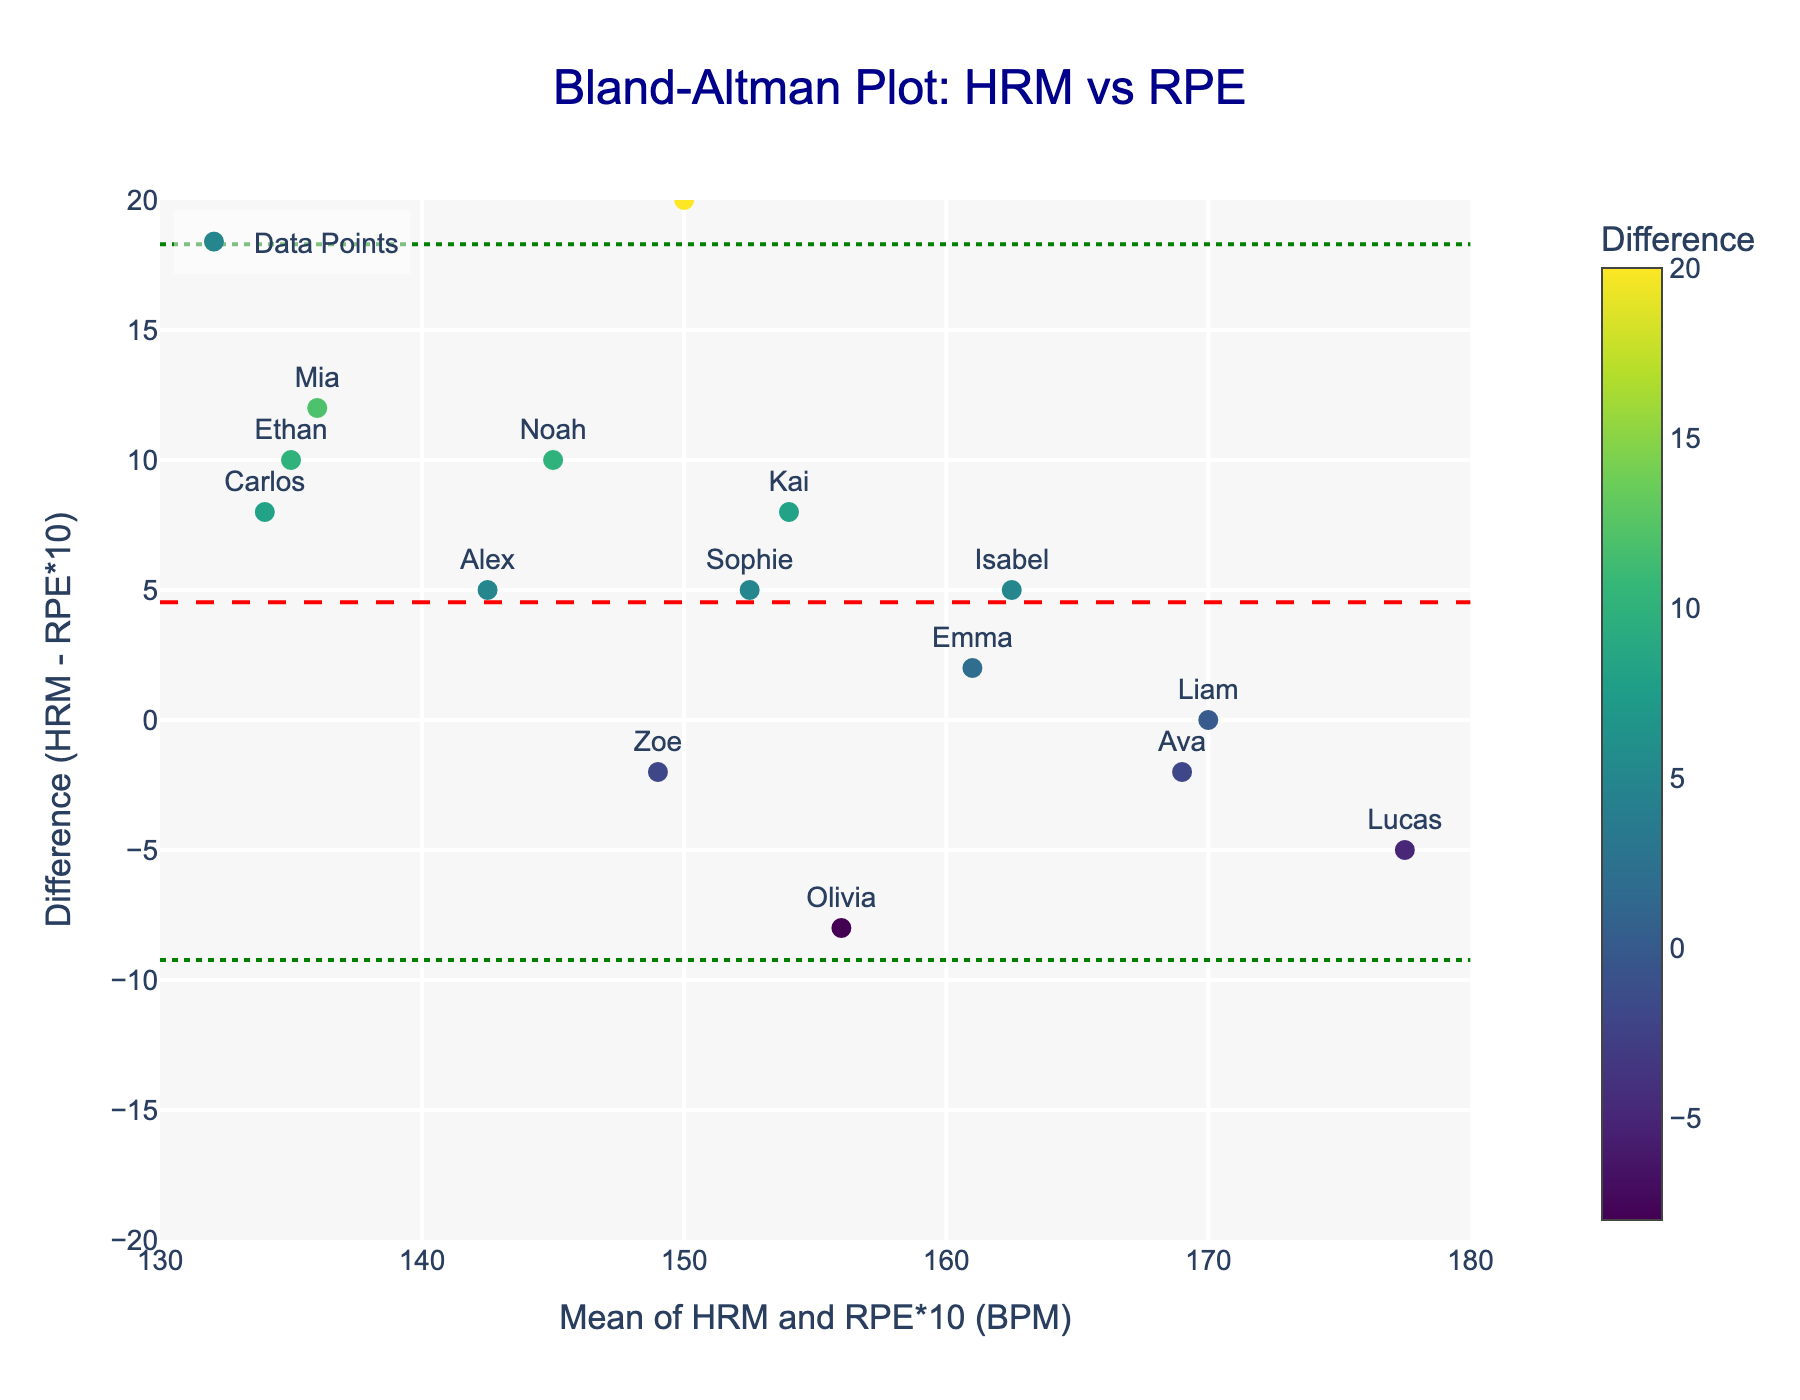What does the title of the plot indicate? The title of the plot is "Bland-Altman Plot: HRM vs RPE," which tells us that the plot is used to compare heart rate monitor (HRM) data with perceived exertion ratings (RPE) and check their agreement.
Answer: It compares HRM and RPE What are the ranges of the x-axis and y-axis in the plot? The x-axis ranges from approximately 130 to 180 BPM, and the y-axis ranges from -20 to 20 BPM. This represents the mean of HRM and RPE*10 on the x-axis, and the difference between HRM and RPE*10 on the y-axis.
Answer: x: 130-180, y: -20 to 20 What color are the dots representing the data points? The dots representing the data points are in various shades of a "Viridis" color scale, which ranges from yellow to dark blue.
Answer: Various shades of "Viridis" color scale What player has the closest difference between HRM and RPE*10? To find the player with the closest difference, look for the dot closest to the y-axis of 0 BPM. Sophie has a difference of 0.
Answer: Sophie What is the mean difference between HRM and RPE*10? The mean difference is represented by the red dashed line. It is shown at approximately 0 BPM.
Answer: 0 BPM What player has the largest negative difference? The largest negative difference can be found by looking at the bottom-most dot. Olivia has a difference of -4 BPM.
Answer: Olivia If three players had differences of 1, 1, and -2, what would be their average difference? First, add the differences: 1 + 1 + (-2) = 0. Then, divide by the number of players: 0 / 3 = 0.
Answer: 0 What are the limits of agreement (LOA) in the plot? Limits of Agreement (LOA) are represented by the green dotted lines. The upper LOA is approximately at +8, and the lower LOA is approximately at -8.
Answer: upper: +8, lower: -8 Which player's data point is represented by the farthest dot on the right side of the plot? The farthest dot on the right side represents Lucas, whose mean is approximately 175 BPM.
Answer: Lucas How many players have a positive difference between HRM and RPE*10? Count the dots that are above the y = 0 line. There are five such players: Alex, Carlos, Mia, Kai, and Noah.
Answer: 5 